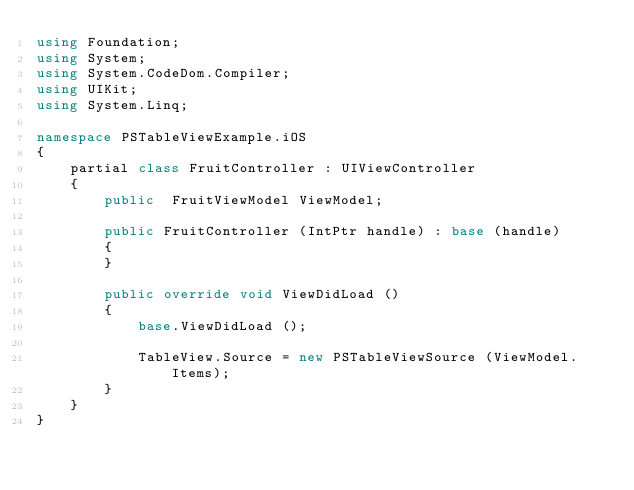Convert code to text. <code><loc_0><loc_0><loc_500><loc_500><_C#_>using Foundation;
using System;
using System.CodeDom.Compiler;
using UIKit;
using System.Linq;

namespace PSTableViewExample.iOS
{
	partial class FruitController : UIViewController
	{
		public  FruitViewModel ViewModel;

		public FruitController (IntPtr handle) : base (handle)
		{
		}

		public override void ViewDidLoad ()
		{
			base.ViewDidLoad ();

			TableView.Source = new PSTableViewSource (ViewModel.Items);
		}
	}
}
</code> 